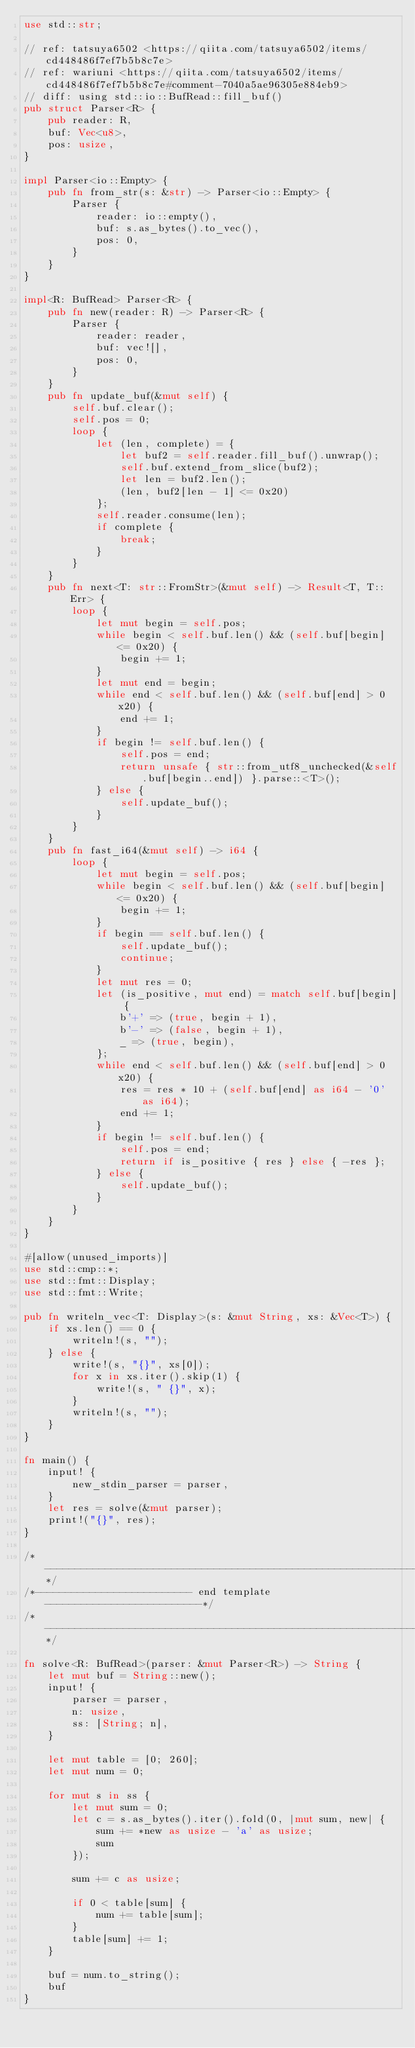<code> <loc_0><loc_0><loc_500><loc_500><_Rust_>use std::str;

// ref: tatsuya6502 <https://qiita.com/tatsuya6502/items/cd448486f7ef7b5b8c7e>
// ref: wariuni <https://qiita.com/tatsuya6502/items/cd448486f7ef7b5b8c7e#comment-7040a5ae96305e884eb9>
// diff: using std::io::BufRead::fill_buf()
pub struct Parser<R> {
    pub reader: R,
    buf: Vec<u8>,
    pos: usize,
}

impl Parser<io::Empty> {
    pub fn from_str(s: &str) -> Parser<io::Empty> {
        Parser {
            reader: io::empty(),
            buf: s.as_bytes().to_vec(),
            pos: 0,
        }
    }
}

impl<R: BufRead> Parser<R> {
    pub fn new(reader: R) -> Parser<R> {
        Parser {
            reader: reader,
            buf: vec![],
            pos: 0,
        }
    }
    pub fn update_buf(&mut self) {
        self.buf.clear();
        self.pos = 0;
        loop {
            let (len, complete) = {
                let buf2 = self.reader.fill_buf().unwrap();
                self.buf.extend_from_slice(buf2);
                let len = buf2.len();
                (len, buf2[len - 1] <= 0x20)
            };
            self.reader.consume(len);
            if complete {
                break;
            }
        }
    }
    pub fn next<T: str::FromStr>(&mut self) -> Result<T, T::Err> {
        loop {
            let mut begin = self.pos;
            while begin < self.buf.len() && (self.buf[begin] <= 0x20) {
                begin += 1;
            }
            let mut end = begin;
            while end < self.buf.len() && (self.buf[end] > 0x20) {
                end += 1;
            }
            if begin != self.buf.len() {
                self.pos = end;
                return unsafe { str::from_utf8_unchecked(&self.buf[begin..end]) }.parse::<T>();
            } else {
                self.update_buf();
            }
        }
    }
    pub fn fast_i64(&mut self) -> i64 {
        loop {
            let mut begin = self.pos;
            while begin < self.buf.len() && (self.buf[begin] <= 0x20) {
                begin += 1;
            }
            if begin == self.buf.len() {
                self.update_buf();
                continue;
            }
            let mut res = 0;
            let (is_positive, mut end) = match self.buf[begin] {
                b'+' => (true, begin + 1),
                b'-' => (false, begin + 1),
                _ => (true, begin),
            };
            while end < self.buf.len() && (self.buf[end] > 0x20) {
                res = res * 10 + (self.buf[end] as i64 - '0' as i64);
                end += 1;
            }
            if begin != self.buf.len() {
                self.pos = end;
                return if is_positive { res } else { -res };
            } else {
                self.update_buf();
            }
        }
    }
}

#[allow(unused_imports)]
use std::cmp::*;
use std::fmt::Display;
use std::fmt::Write;

pub fn writeln_vec<T: Display>(s: &mut String, xs: &Vec<T>) {
    if xs.len() == 0 {
        writeln!(s, "");
    } else {
        write!(s, "{}", xs[0]);
        for x in xs.iter().skip(1) {
            write!(s, " {}", x);
        }
        writeln!(s, "");
    }
}

fn main() {
    input! {
        new_stdin_parser = parser,
    }
    let res = solve(&mut parser);
    print!("{}", res);
}

/*------------------------------------------------------------------*/
/*-------------------------- end template --------------------------*/
/*------------------------------------------------------------------*/

fn solve<R: BufRead>(parser: &mut Parser<R>) -> String {
    let mut buf = String::new();
    input! {
        parser = parser,
        n: usize,
        ss: [String; n],
    }

    let mut table = [0; 260];
    let mut num = 0;

    for mut s in ss {
        let mut sum = 0;
        let c = s.as_bytes().iter().fold(0, |mut sum, new| {
            sum += *new as usize - 'a' as usize;
            sum
        });

        sum += c as usize;

        if 0 < table[sum] {
            num += table[sum];
        }
        table[sum] += 1;
    }

    buf = num.to_string();
    buf
}
</code> 